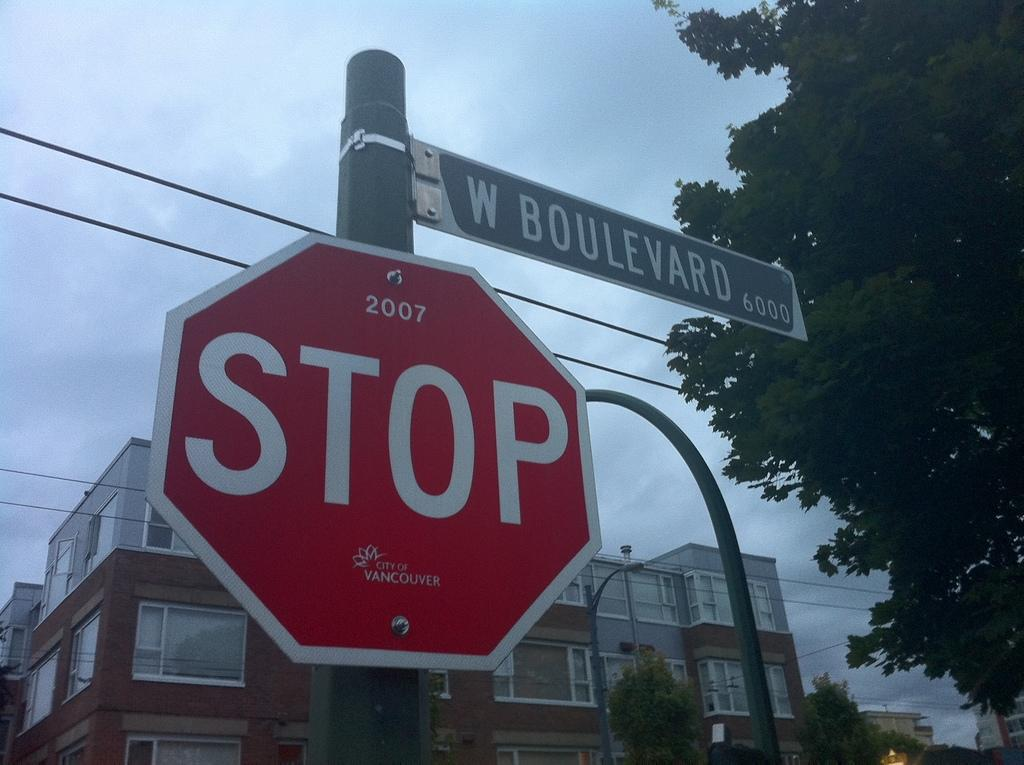<image>
Give a short and clear explanation of the subsequent image. A red stop sign has a green street sign above it that says W Boulevard. 